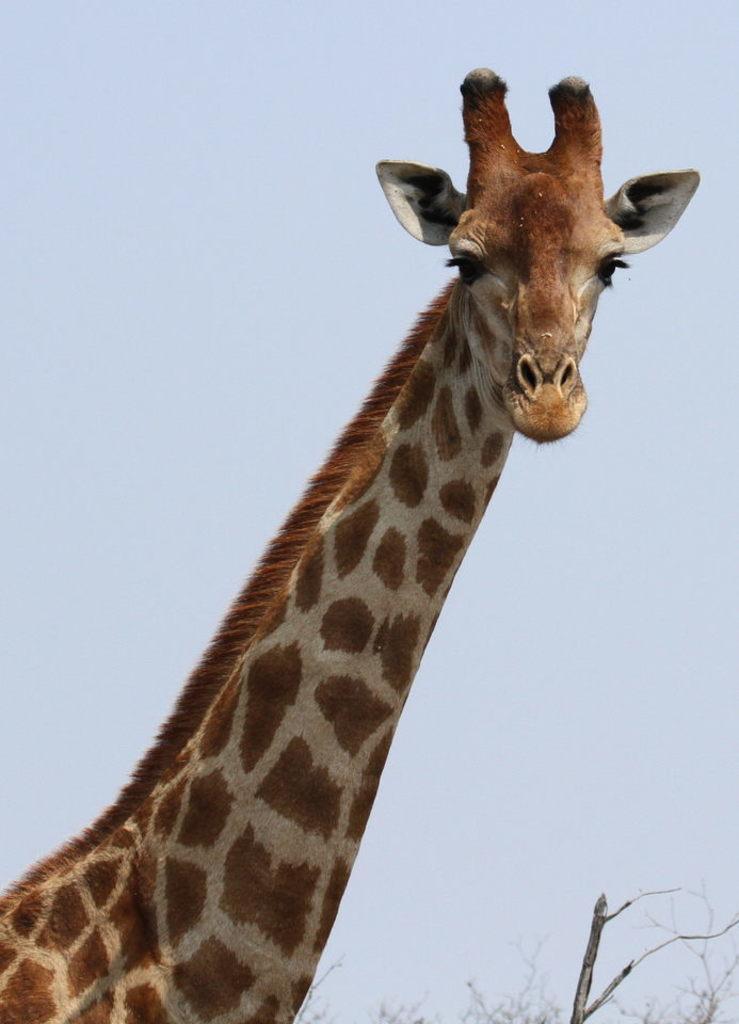How would you summarize this image in a sentence or two? In this image we can see a giraffe, trees and sky. 